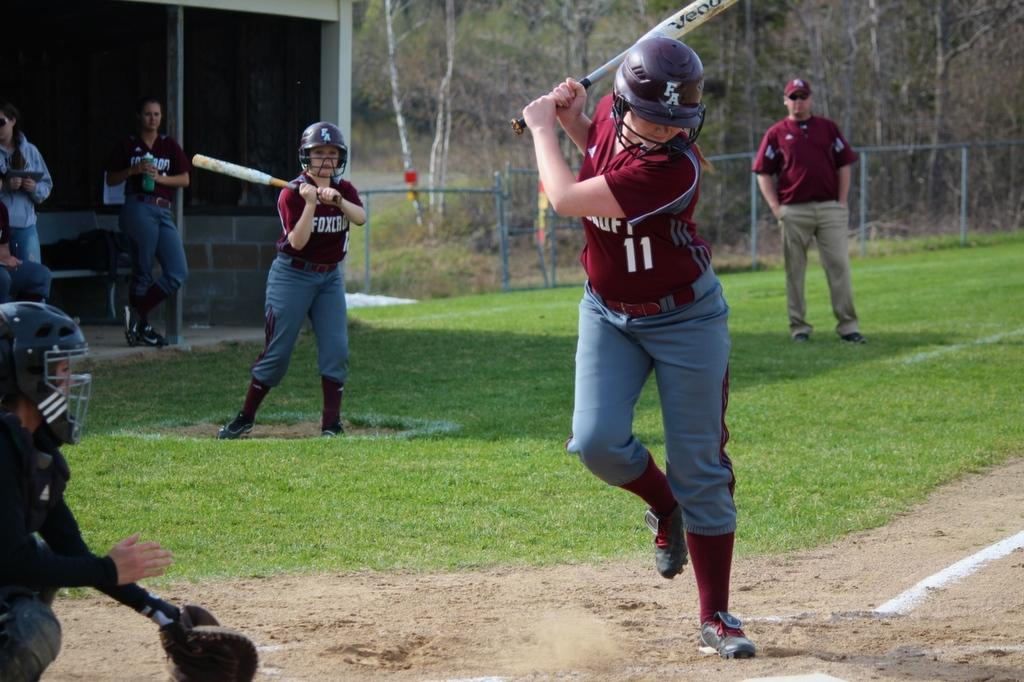<image>
Render a clear and concise summary of the photo. Baseball player wearing a jersey with the number 11 